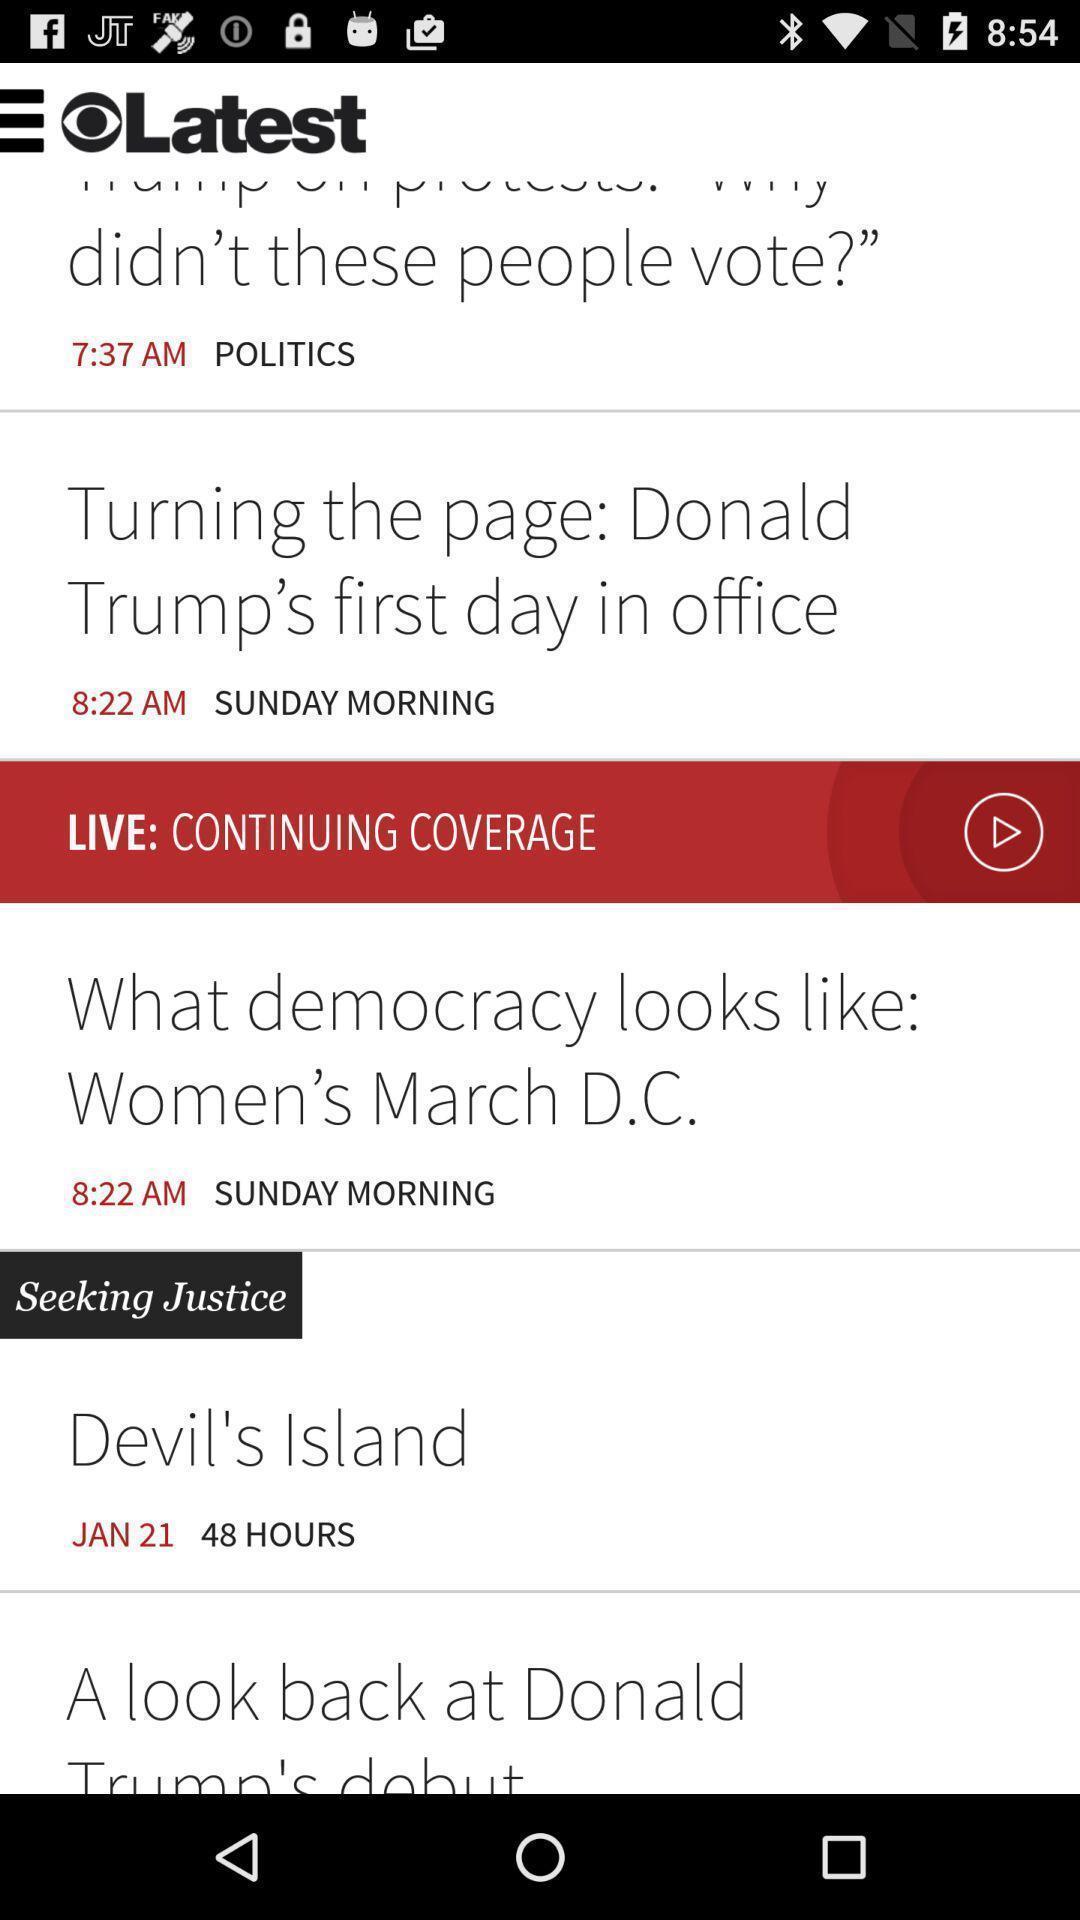Summarize the information in this screenshot. Screen shows list of articles in a news app. 